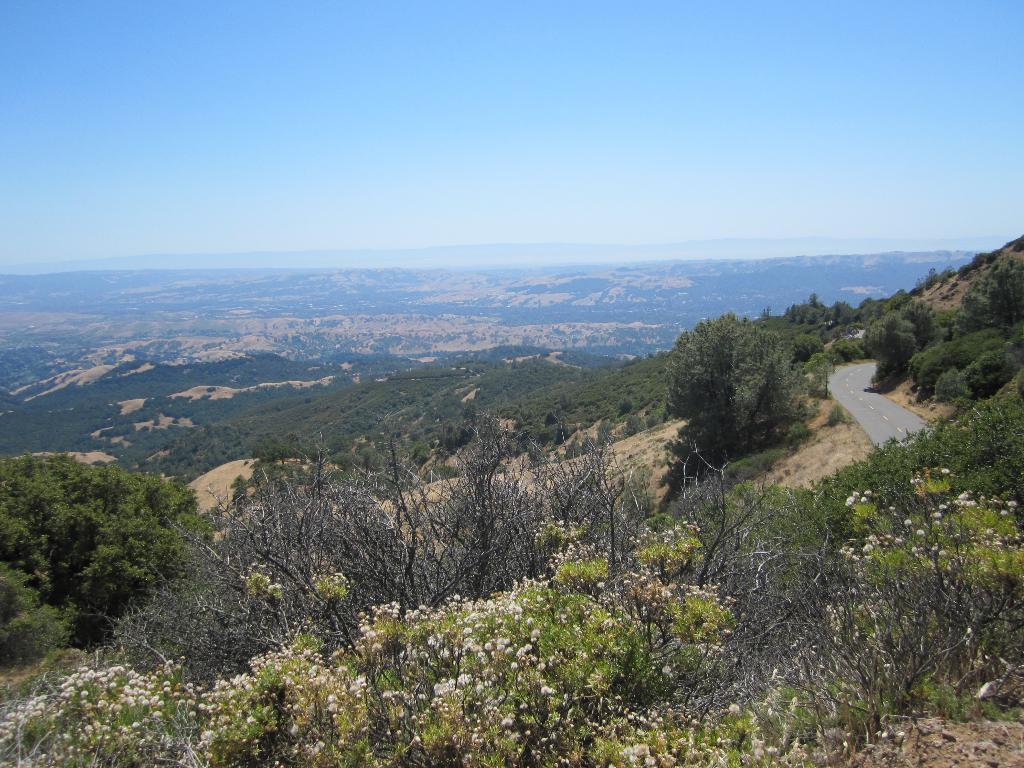In one or two sentences, can you explain what this image depicts? In this picture we can see the road, trees, mountains and in the background we can see the sky. 